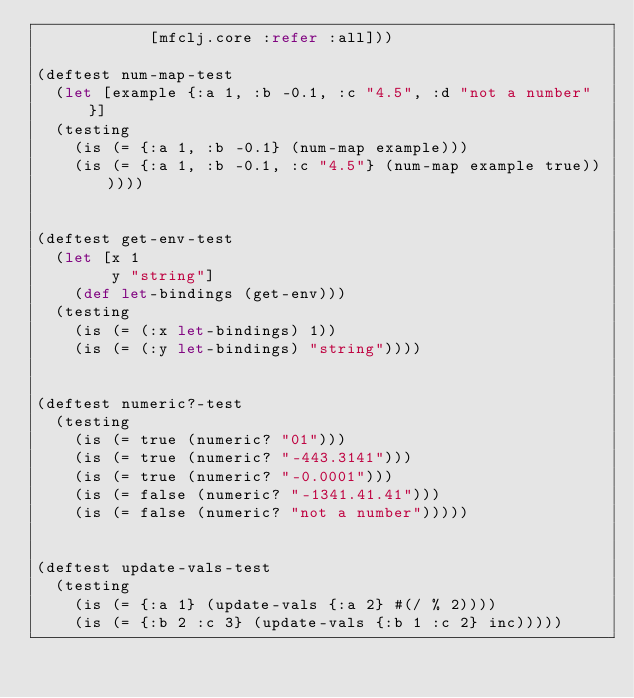Convert code to text. <code><loc_0><loc_0><loc_500><loc_500><_Clojure_>            [mfclj.core :refer :all]))

(deftest num-map-test
  (let [example {:a 1, :b -0.1, :c "4.5", :d "not a number"}]
  (testing
    (is (= {:a 1, :b -0.1} (num-map example)))
    (is (= {:a 1, :b -0.1, :c "4.5"} (num-map example true))))))


(deftest get-env-test
  (let [x 1
        y "string"]
    (def let-bindings (get-env)))
  (testing
    (is (= (:x let-bindings) 1))
    (is (= (:y let-bindings) "string"))))


(deftest numeric?-test
  (testing
    (is (= true (numeric? "01")))
    (is (= true (numeric? "-443.3141")))
    (is (= true (numeric? "-0.0001")))
    (is (= false (numeric? "-1341.41.41")))
    (is (= false (numeric? "not a number")))))


(deftest update-vals-test
  (testing
    (is (= {:a 1} (update-vals {:a 2} #(/ % 2))))
    (is (= {:b 2 :c 3} (update-vals {:b 1 :c 2} inc)))))
</code> 